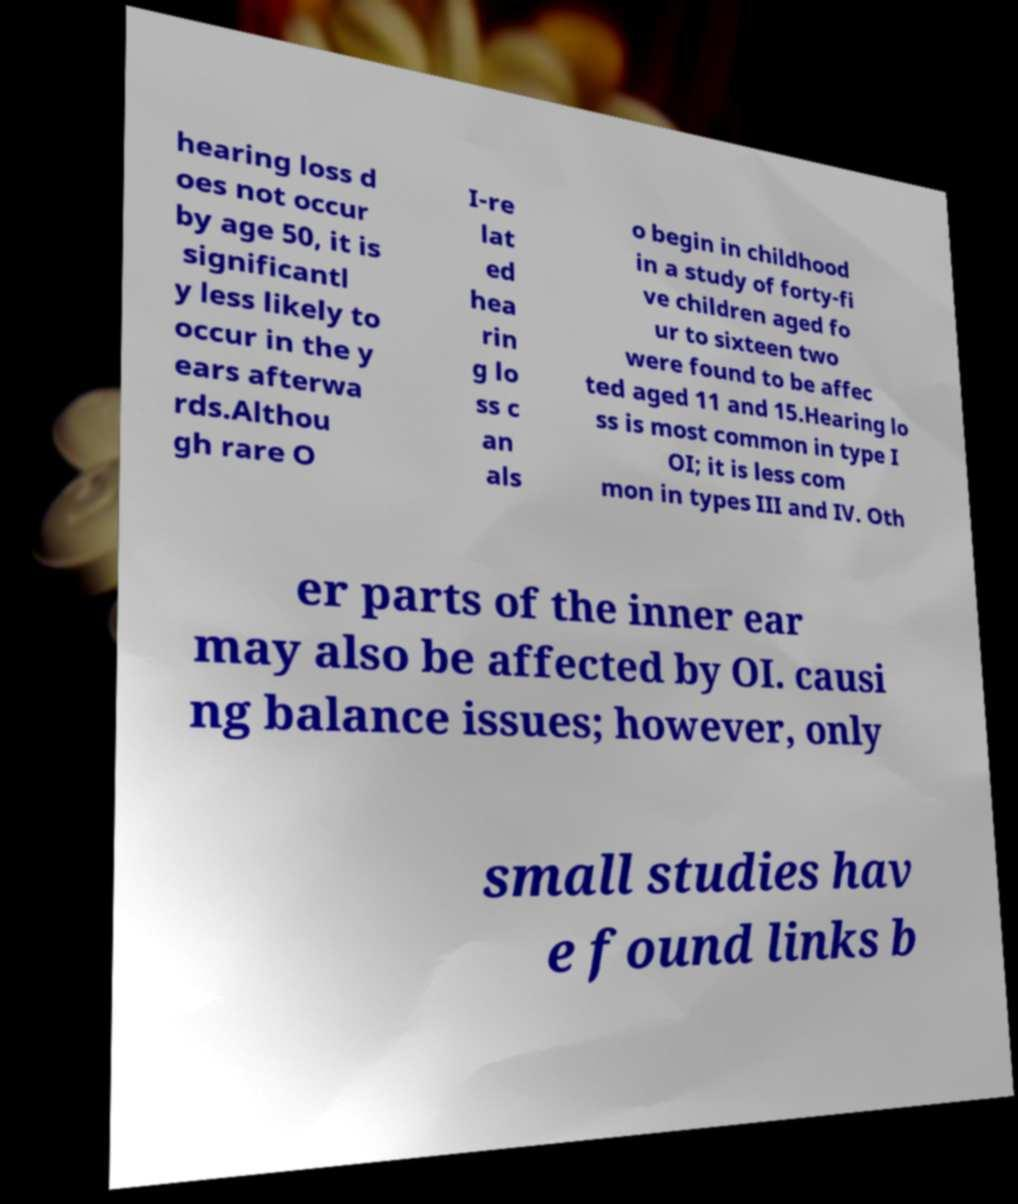Can you read and provide the text displayed in the image?This photo seems to have some interesting text. Can you extract and type it out for me? hearing loss d oes not occur by age 50, it is significantl y less likely to occur in the y ears afterwa rds.Althou gh rare O I-re lat ed hea rin g lo ss c an als o begin in childhood in a study of forty-fi ve children aged fo ur to sixteen two were found to be affec ted aged 11 and 15.Hearing lo ss is most common in type I OI; it is less com mon in types III and IV. Oth er parts of the inner ear may also be affected by OI. causi ng balance issues; however, only small studies hav e found links b 